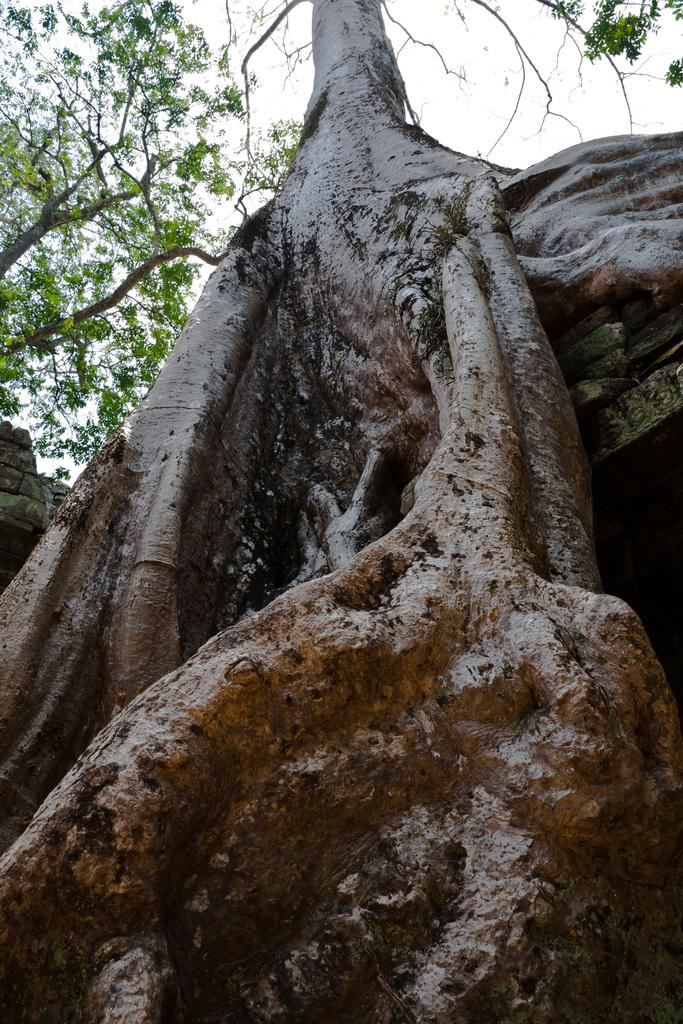What is visible in the center of the image? The sky, clouds, and trees are visible in the center of the image. Are there any other objects present in the center of the image? Yes, there are other objects in the center of the image. How does the tooth get the attention of the clouds in the image? There is no tooth present in the image, so it cannot get the attention of the clouds. 